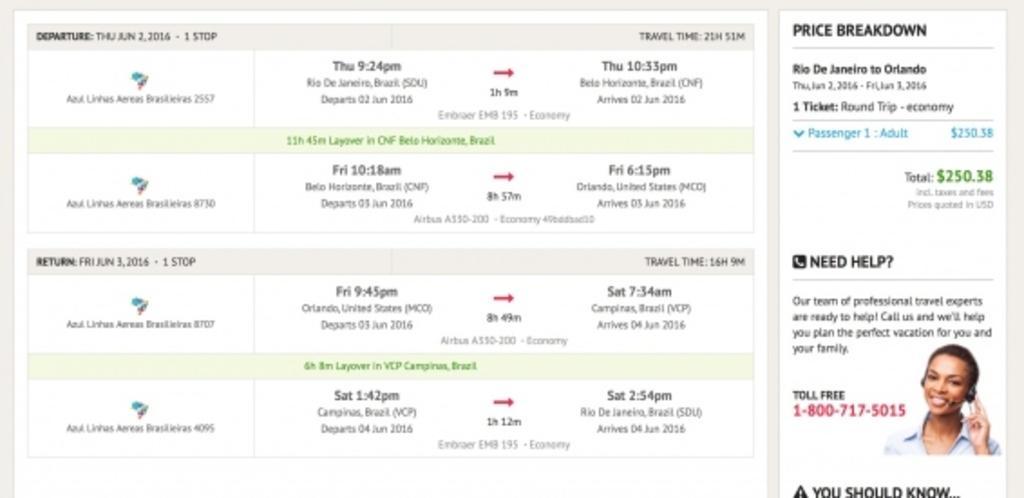How would you summarize this image in a sentence or two? In this image, we can see a screenshot with some image and text. 